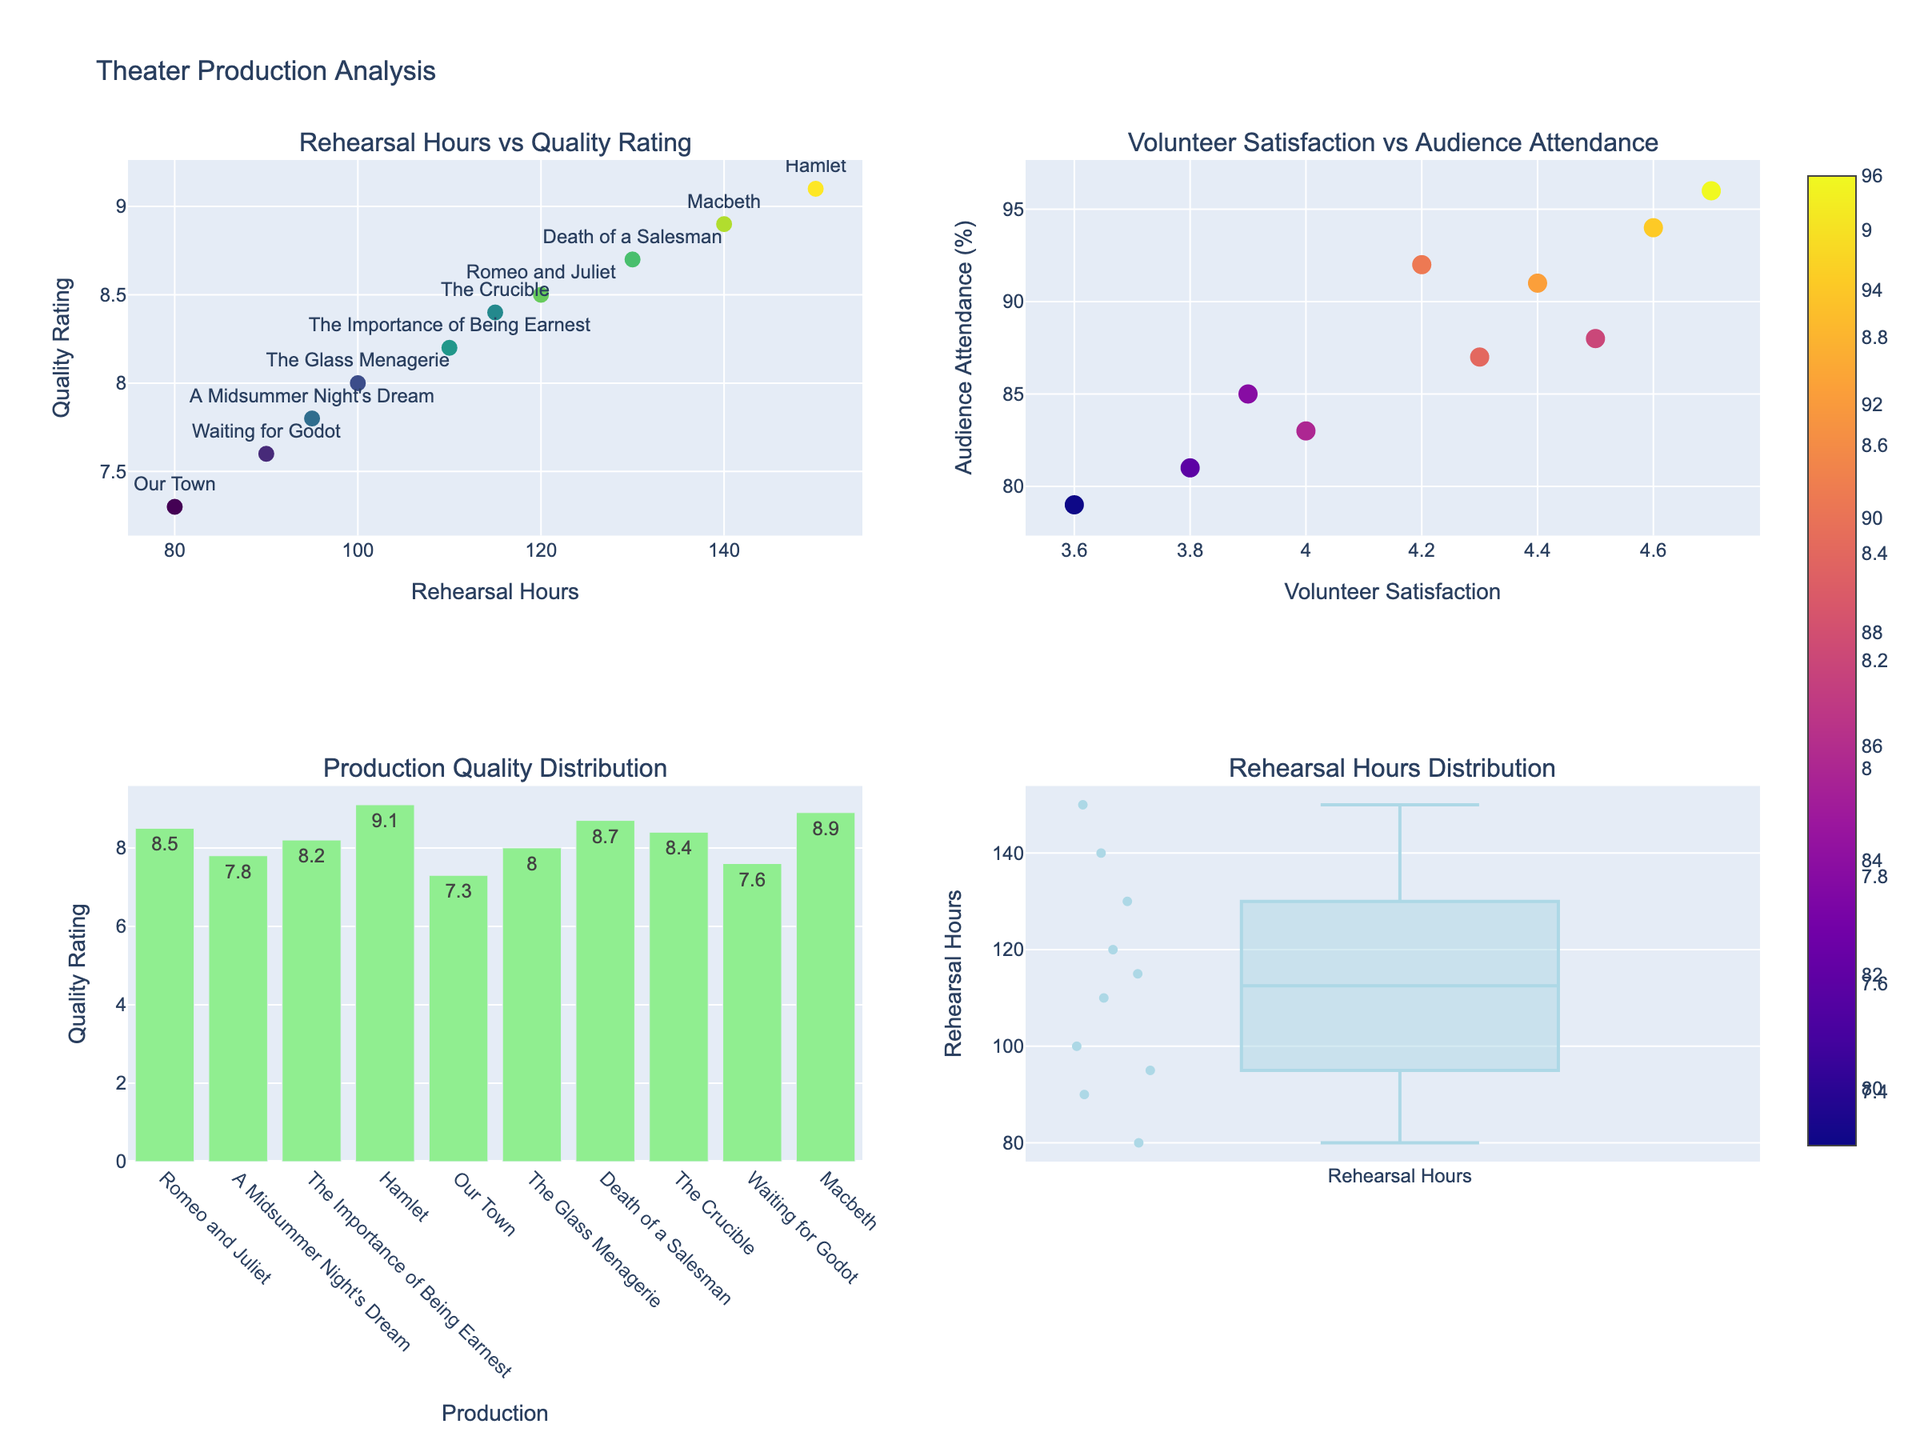What is the title of the figure? The title of the figure is usually located at the top of the plot. In this case, it is clearly stated as "Theater Production Analysis".
Answer: Theater Production Analysis How many productions are represented in the scatter plot "Rehearsal Hours vs Quality Rating"? By counting the number of data points (marker points) in the scatter plot located in the top-left corner, we can see that there are 10 data points, each representing a different production.
Answer: 10 Which production has the highest quality rating, and what is that rating? The scatter plot "Rehearsal Hours vs Quality Rating" shows markers with text labels indicating production names. By identifying the highest point on the y-axis (Quality Rating), we see that "Hamlet" has the highest rating, which is 9.1.
Answer: Hamlet, 9.1 What is the color used for the bars in the "Production Quality Distribution" plot? In the bar chart located in the bottom-left, all bars are uniformly colored. The visual observation shows that the bars are colored light green.
Answer: Light green Which production has the lowest audience attendance, and what is its attendance percentage? By examining the scatter plot "Volunteer Satisfaction vs Audience Attendance" on the top-right, and finding the lowest point on the y-axis (Audience Attendance), we see that "Our Town" has the lowest attendance, which is 79%.
Answer: Our Town, 79% What is the range of rehearsal hours as depicted in the box plot? The box plot located in the bottom-right corner shows the distribution of rehearsal hours. By identifying the minimum and maximum points, it is evident that the range is from 80 hours to 150 hours.
Answer: 80 to 150 hours Which production had the highest volunteer satisfaction and what was the audience attendance for that production? In the scatter plot "Volunteer Satisfaction vs Audience Attendance", identifying the highest point on the x-axis (Volunteer Satisfaction) reveals that "Hamlet" has the highest volunteer satisfaction of 4.7, with an audience attendance of 96%.
Answer: Hamlet, 4.7, 96% Among the productions listed, what is the median quality rating? Examine the quality ratings in the bar chart "Production Quality Distribution". By sorting the quality ratings (7.3, 7.6, 7.8, 8.0, 8.2, 8.4, 8.5, 8.7, 8.9, 9.1) and finding the middle value, the median can be calculated as the average of the 5th (8.2) and 6th (8.4) values, which is (8.2 + 8.4)/2.
Answer: 8.3 Do productions with higher average rehearsal hours tend to have higher quality ratings? By examining the scatter plot "Rehearsal Hours vs Quality Rating", a positive correlation trend can be observed: as rehearsal hours increase, quality ratings seem to generally increase.
Answer: Yes 